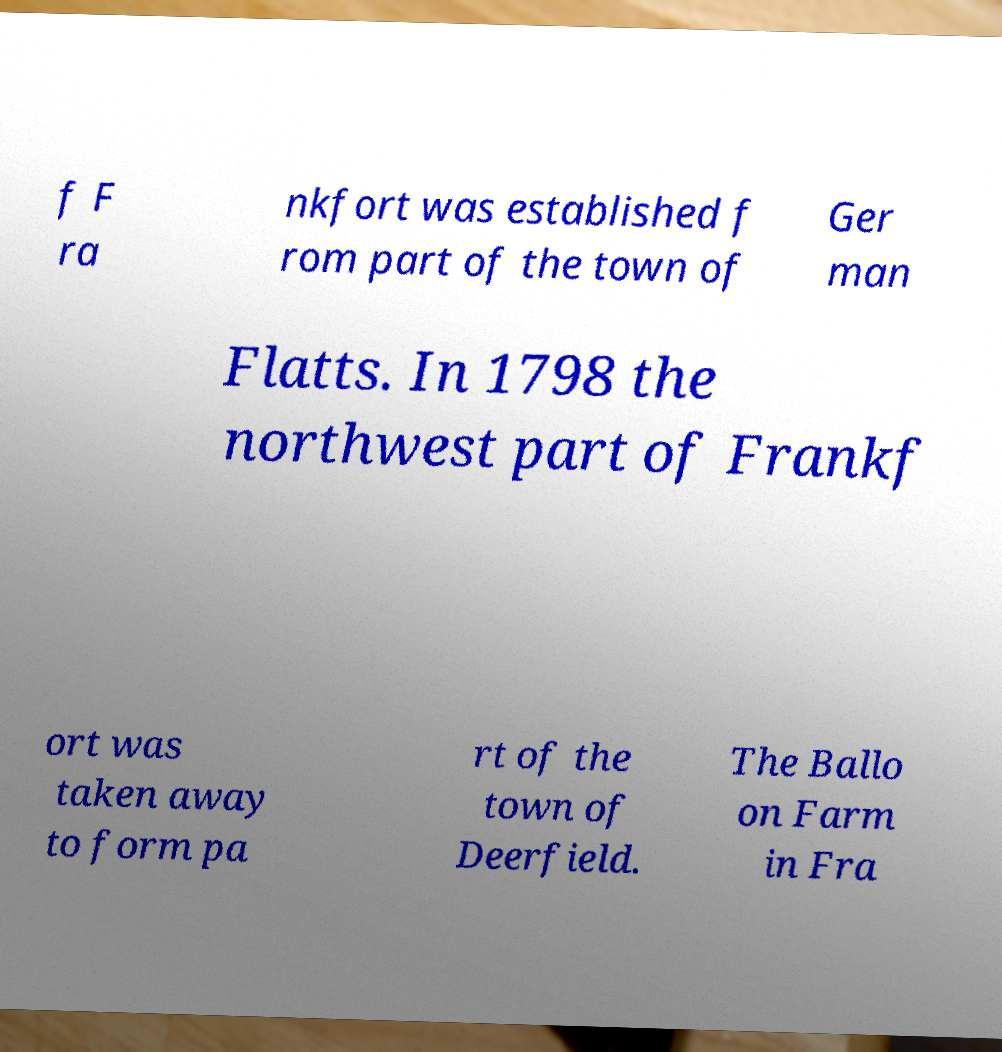For documentation purposes, I need the text within this image transcribed. Could you provide that? f F ra nkfort was established f rom part of the town of Ger man Flatts. In 1798 the northwest part of Frankf ort was taken away to form pa rt of the town of Deerfield. The Ballo on Farm in Fra 